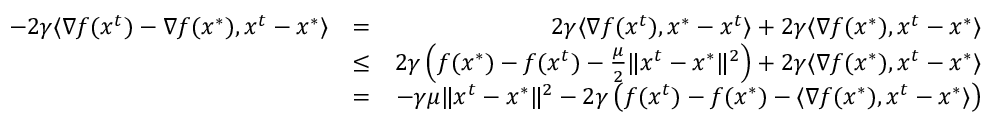<formula> <loc_0><loc_0><loc_500><loc_500>\begin{array} { r l r } { - 2 \gamma \langle \nabla f ( x ^ { t } ) - \nabla f ( x ^ { * } ) , x ^ { t } - x ^ { * } \rangle } & { = } & { 2 \gamma \langle \nabla f ( x ^ { t } ) , x ^ { * } - x ^ { t } \rangle + 2 \gamma \langle \nabla f ( x ^ { * } ) , x ^ { t } - x ^ { * } \rangle } \\ & { \leq } & { 2 \gamma \left ( f ( x ^ { * } ) - f ( x ^ { t } ) - \frac { \mu } { 2 } \| x ^ { t } - x ^ { * } \| ^ { 2 } \right ) + 2 \gamma \langle \nabla f ( x ^ { * } ) , x ^ { t } - x ^ { * } \rangle } \\ & { = } & { - \gamma \mu \| x ^ { t } - x ^ { * } \| ^ { 2 } - 2 \gamma \left ( f ( x ^ { t } ) - f ( x ^ { * } ) - \langle \nabla f ( x ^ { * } ) , x ^ { t } - x ^ { * } \rangle \right ) } \end{array}</formula> 